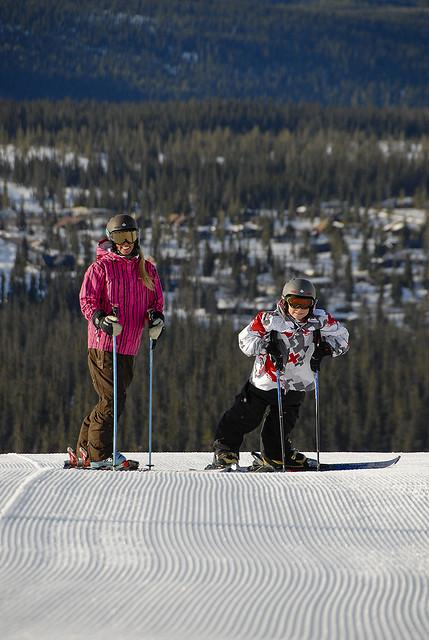What color are the vertical stripes on the left skier's jacket? Please explain your reasoning. black. The jacket is fully visible and the stripes are identifiable and the color can be gleaned. 